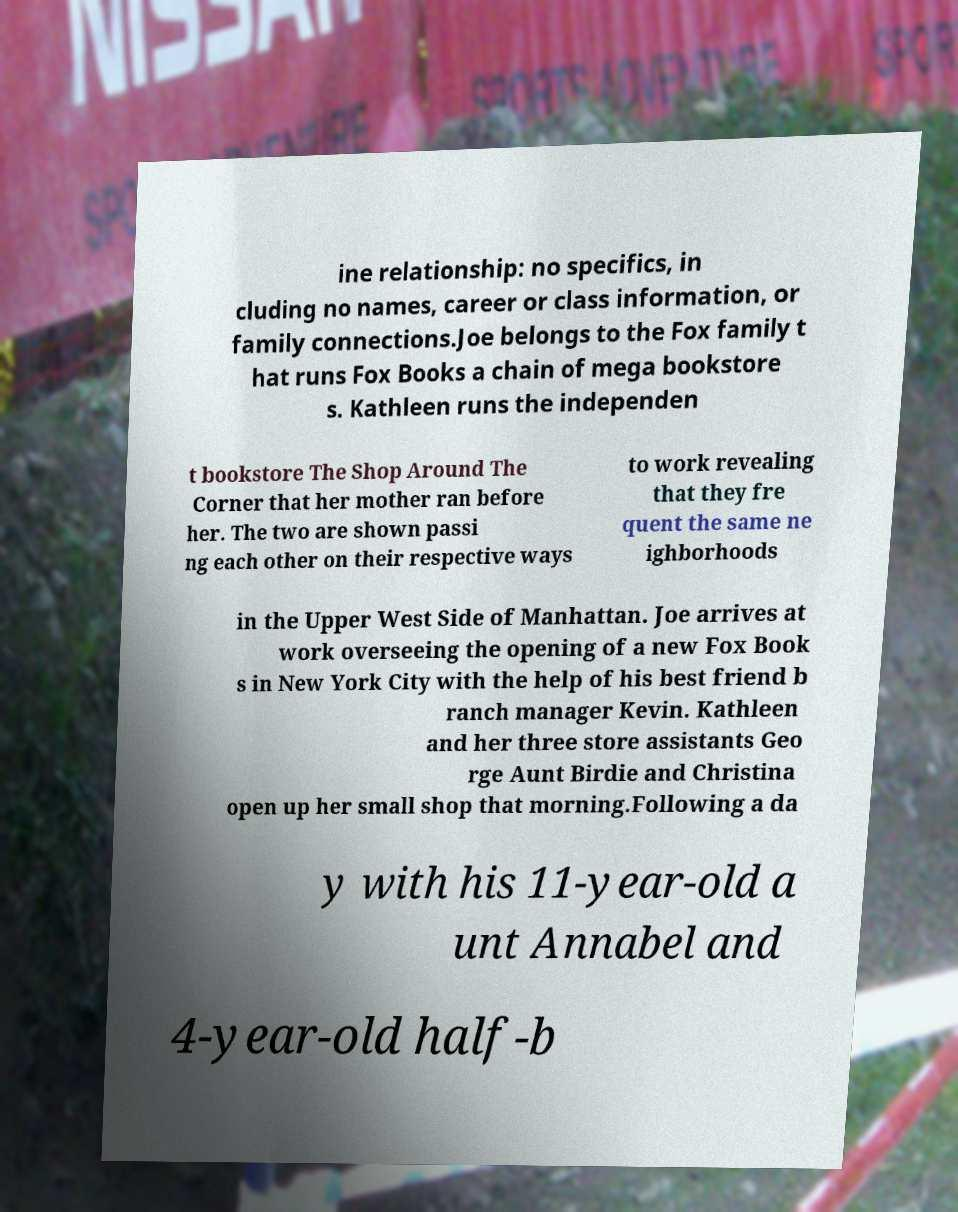Can you read and provide the text displayed in the image?This photo seems to have some interesting text. Can you extract and type it out for me? ine relationship: no specifics, in cluding no names, career or class information, or family connections.Joe belongs to the Fox family t hat runs Fox Books a chain of mega bookstore s. Kathleen runs the independen t bookstore The Shop Around The Corner that her mother ran before her. The two are shown passi ng each other on their respective ways to work revealing that they fre quent the same ne ighborhoods in the Upper West Side of Manhattan. Joe arrives at work overseeing the opening of a new Fox Book s in New York City with the help of his best friend b ranch manager Kevin. Kathleen and her three store assistants Geo rge Aunt Birdie and Christina open up her small shop that morning.Following a da y with his 11-year-old a unt Annabel and 4-year-old half-b 